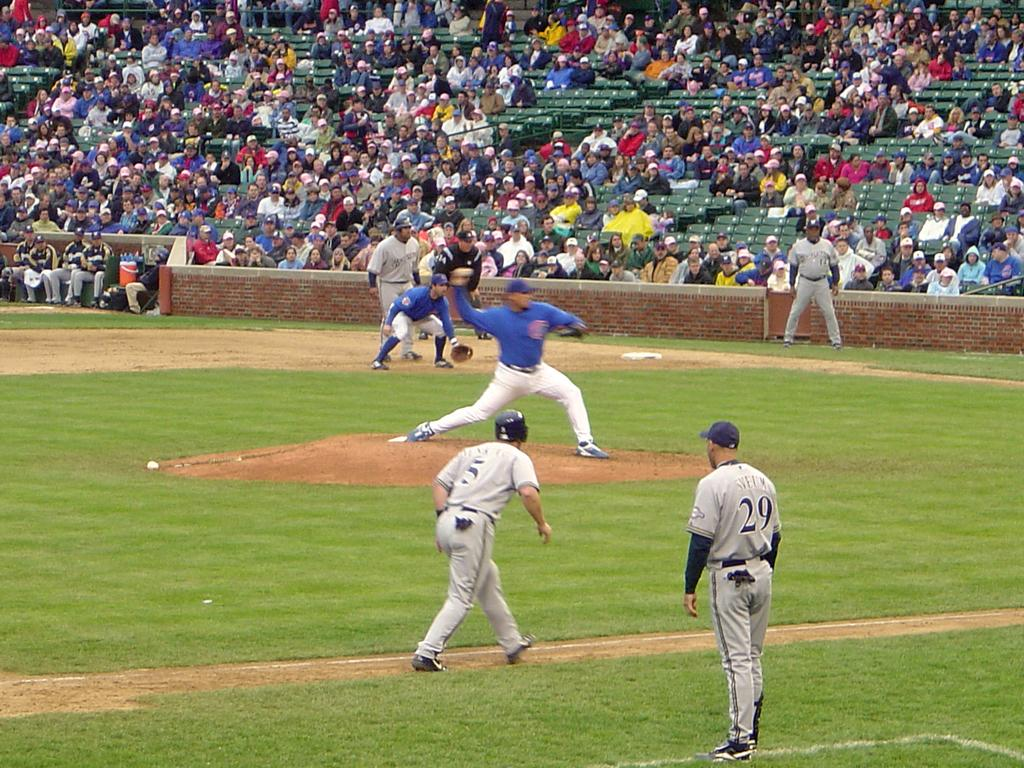Provide a one-sentence caption for the provided image. a baseball player throwing a ball and a coach with the number 29 on. 